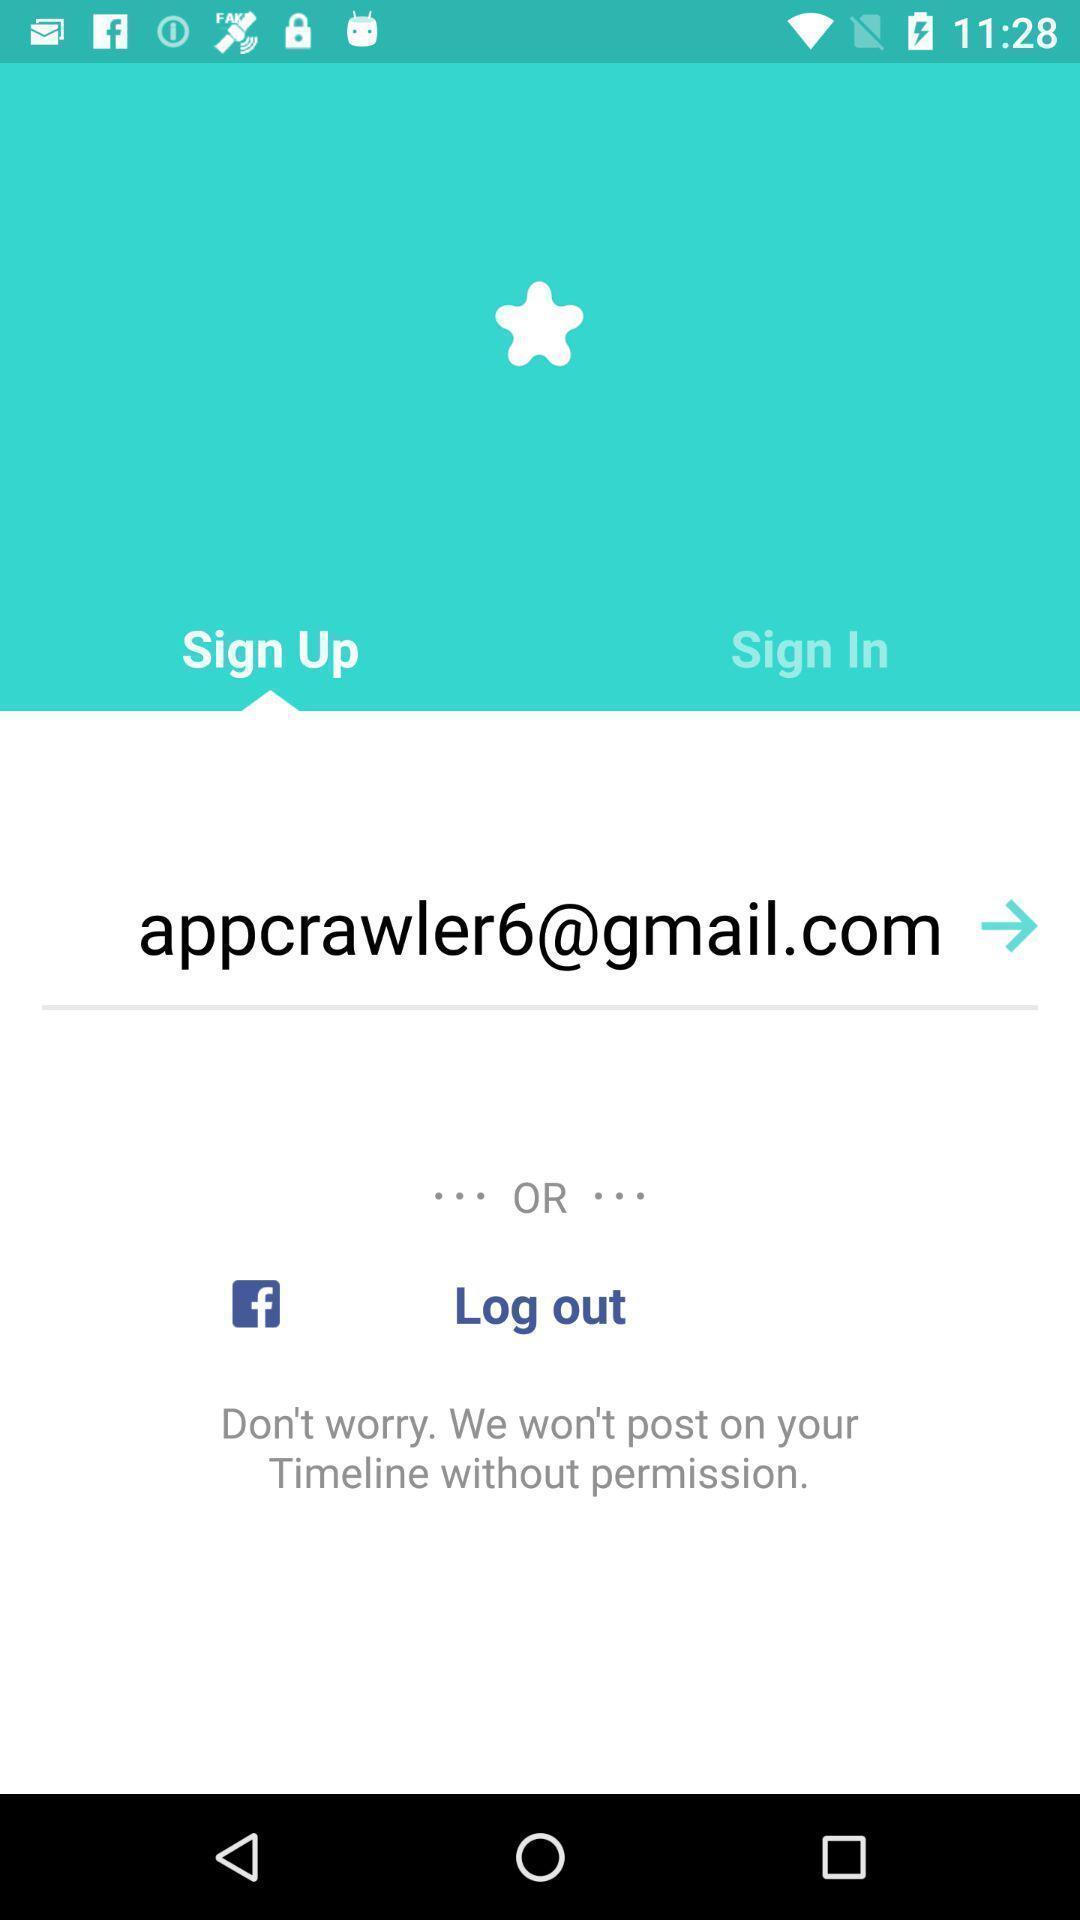Describe this image in words. Sign up page. 